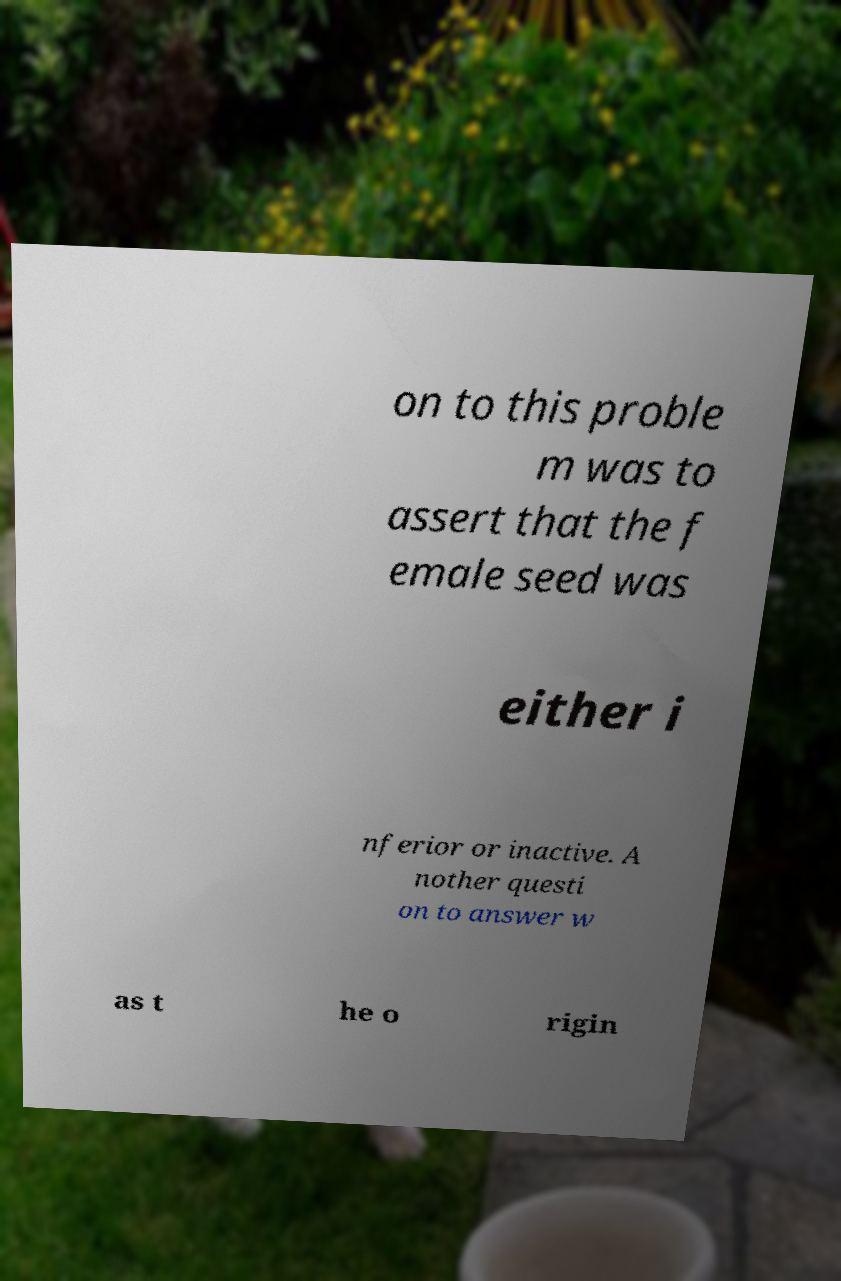Can you read and provide the text displayed in the image?This photo seems to have some interesting text. Can you extract and type it out for me? on to this proble m was to assert that the f emale seed was either i nferior or inactive. A nother questi on to answer w as t he o rigin 